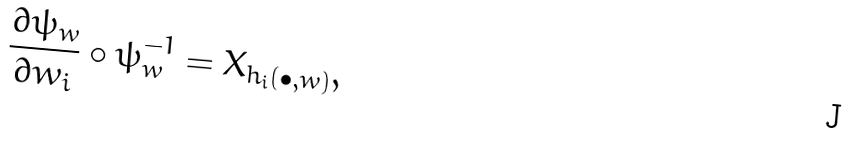<formula> <loc_0><loc_0><loc_500><loc_500>\frac { \partial \psi _ { w } } { \partial w _ { i } } \circ \psi _ { w } ^ { - 1 } = X _ { h _ { i } ( \bullet , w ) } ,</formula> 